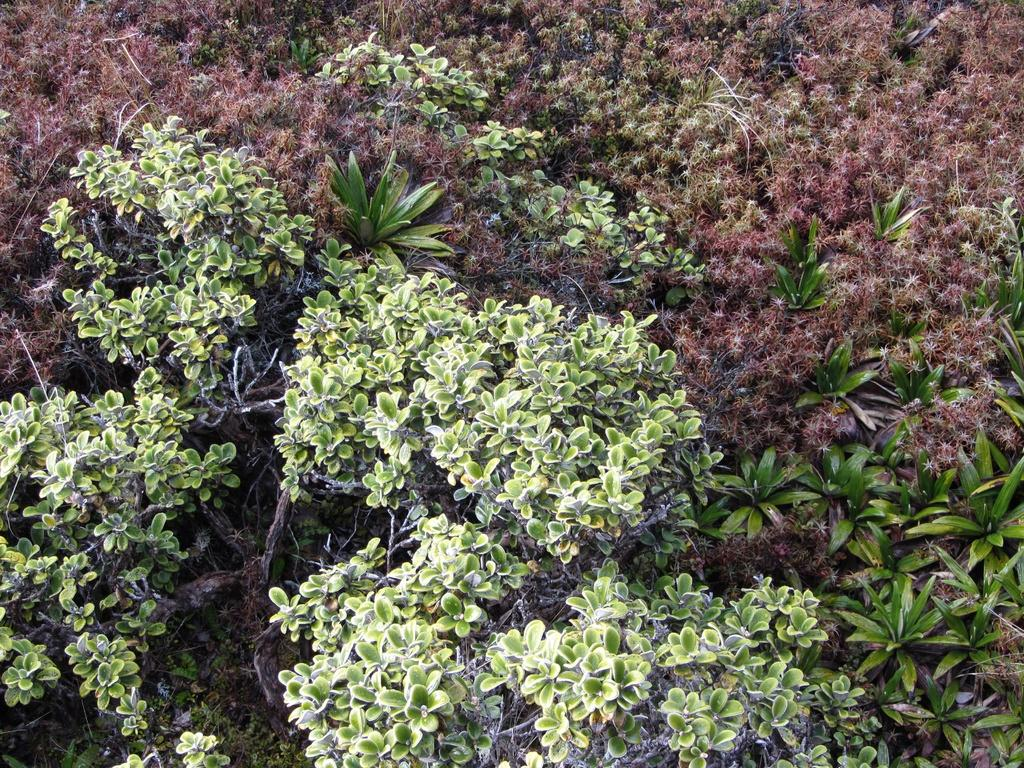What types of living organisms can be seen in the image? Different types of plants can be seen in the image. Can you describe the variety of plants in the image? Unfortunately, the provided facts do not specify the variety of plants in the image. What is the natural setting visible in the image? The natural setting includes the plants, but the specific environment cannot be determined from the given facts. What type of headwear is the plant wearing in the image? There are no plants wearing headwear in the image, as plants do not have the ability to wear clothing or accessories. 